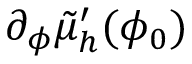Convert formula to latex. <formula><loc_0><loc_0><loc_500><loc_500>\partial _ { \phi } \tilde { \mu } _ { h } ^ { \prime } ( \phi _ { 0 } )</formula> 